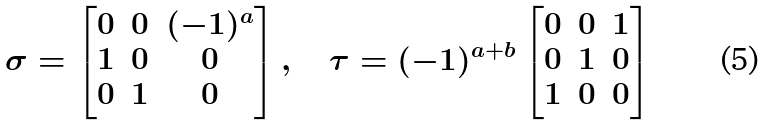<formula> <loc_0><loc_0><loc_500><loc_500>\sigma = \begin{bmatrix} 0 & 0 & ( - 1 ) ^ { a } \\ 1 & 0 & 0 \\ 0 & 1 & 0 \end{bmatrix} , \quad \tau = ( - 1 ) ^ { a + b } \begin{bmatrix} 0 & 0 & 1 \\ 0 & 1 & 0 \\ 1 & 0 & 0 \end{bmatrix}</formula> 